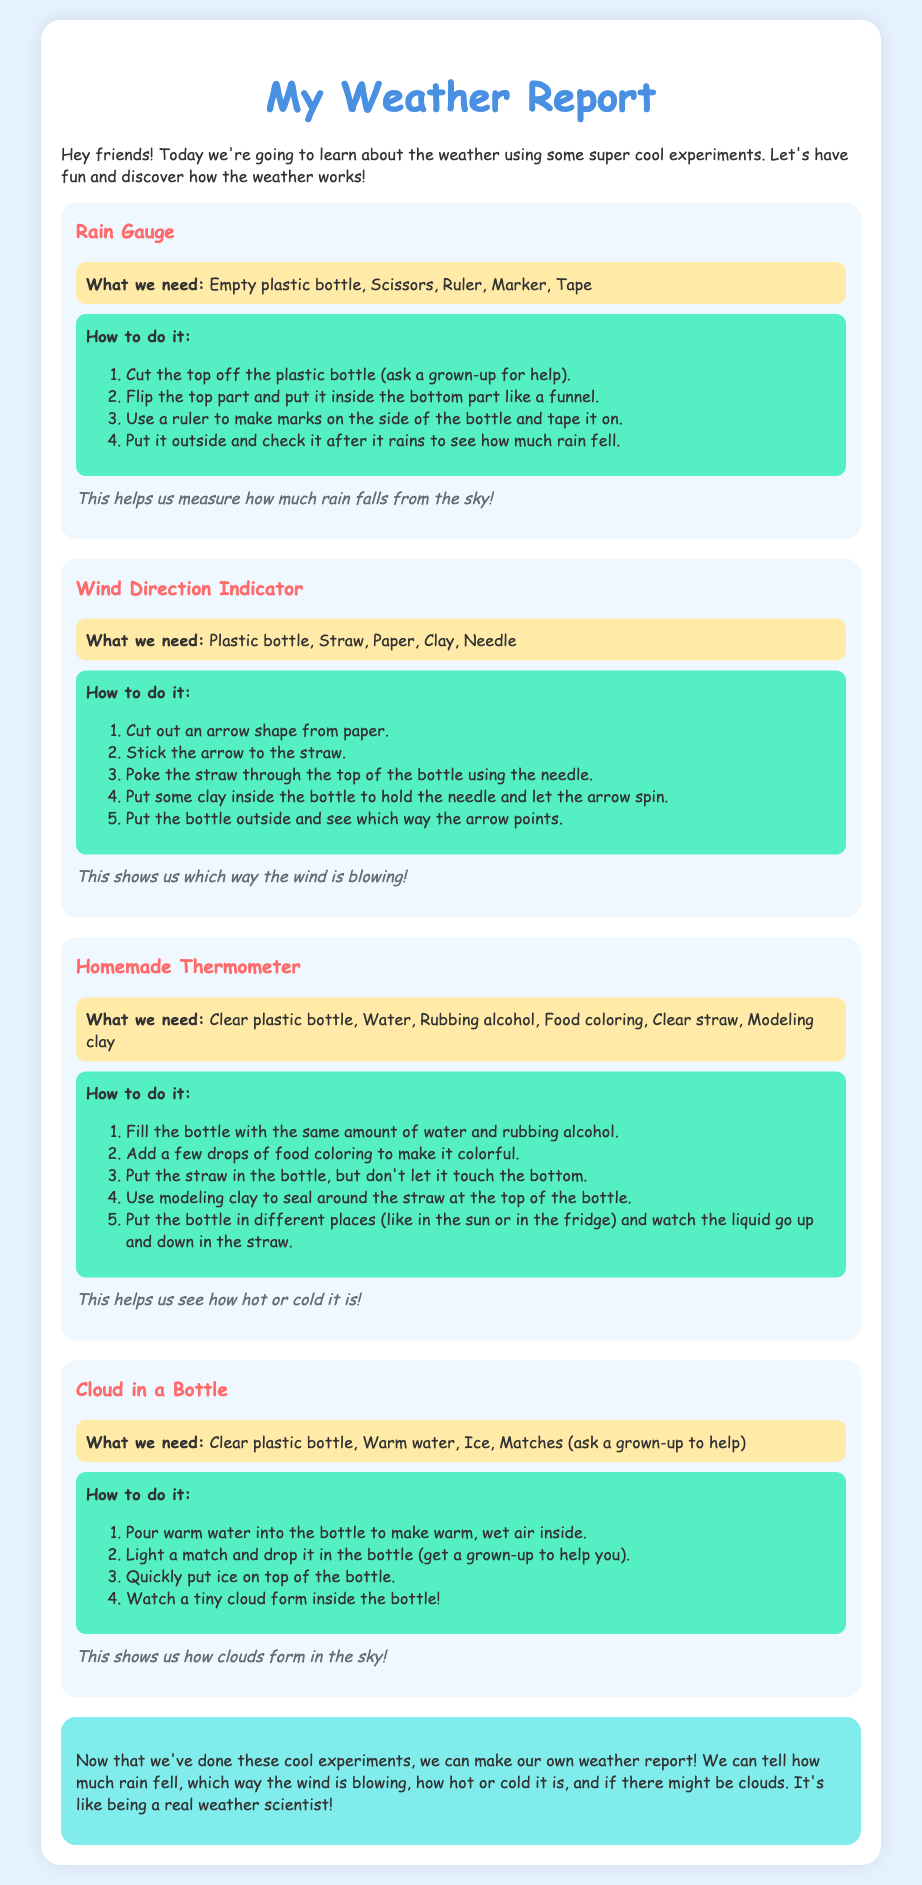What is the title of the document? The title of the document is specified in the HTML code as the content of the title tag.
Answer: My Weather Report What is the first experiment listed? The first experiment is the one titled as the first h3 element in the document.
Answer: Rain Gauge What materials are needed for a homemade thermometer? The materials are specified under the "What we need" section of the Homemade Thermometer experiment.
Answer: Clear plastic bottle, Water, Rubbing alcohol, Food coloring, Clear straw, Modeling clay How many steps are there in the Rain Gauge experiment? The number of steps can be counted from the ordered list in the instructions section of the Rain Gauge experiment.
Answer: 4 What type of bottle is used for the Cloud in a Bottle experiment? The type of bottle is mentioned in the materials section of the Cloud in a Bottle experiment.
Answer: Clear plastic bottle What does the homemade thermometer help us see? The purpose section of the Homemade Thermometer experiment explains its function.
Answer: how hot or cold it is What should you do after pouring warm water in the Cloud in a Bottle experiment? The next action is detailed in the instructions following pouring warm water into the bottle.
Answer: Light a match and drop it in the bottle What color is the background of the document? The background color is set in the style for the body element.
Answer: #e6f3ff What is the conclusion about the experiments? The conclusion summarizes what we can determine after completing the experiments as stated in the conclusion section.
Answer: we can make our own weather report 